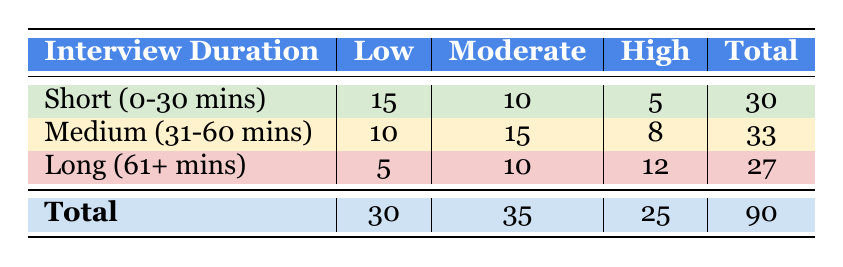What is the total number of interviews conducted? To find the total number of interviews, we sum the total counts across all interview duration categories: 30 (Short) + 33 (Medium) + 27 (Long) = 90.
Answer: 90 How many interviews resulted in high emotional distress during medium-duration interviews? When looking at the medium duration row, the count for high emotional distress is 8.
Answer: 8 Which interview duration had the highest count of low emotional distress? The highest count of low emotional distress can be found by comparing the low emotional distress counts across the three durations: 15 (Short) > 10 (Medium) > 5 (Long), so the answer is Short.
Answer: Short (0-30 mins) Is it true that more than half of the interviews resulted in moderate emotional distress? Total moderate emotional distress is 35 out of 90 total interviews, which is about 38.89%. Since 35 is not more than half of 90 (which would be 45), the statement is false.
Answer: No What is the average number of interviews for each emotional distress level across all durations? To find the average for each level, sum the counts (Low: 30, Moderate: 35, High: 25) and divide by the number of interview durations (3): Low average = 30/3 = 10, Moderate average = 35/3 ≈ 11.67, High average = 25/3 ≈ 8.33.
Answer: Low: 10, Moderate: 11.67, High: 8.33 How many interviews had a low emotional distress level for the long duration? From the table, the count for low emotional distress in the long duration row is 5.
Answer: 5 Which emotional distress level had the highest total count across all interview durations? We sum the counts for each level: Low = 30, Moderate = 35, High = 25. The highest total count is for the Moderate level, which has 35.
Answer: Moderate What is the difference in the number of interviews with high emotional distress between short and long durations? For high emotional distress, the short duration has 5 interviews and the long duration has 12. The difference is 12 - 5 = 7.
Answer: 7 How many interviews had a moderate emotional distress level in the short duration? The count for moderate emotional distress in the short duration row is 10.
Answer: 10 